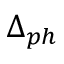<formula> <loc_0><loc_0><loc_500><loc_500>\Delta _ { p h }</formula> 